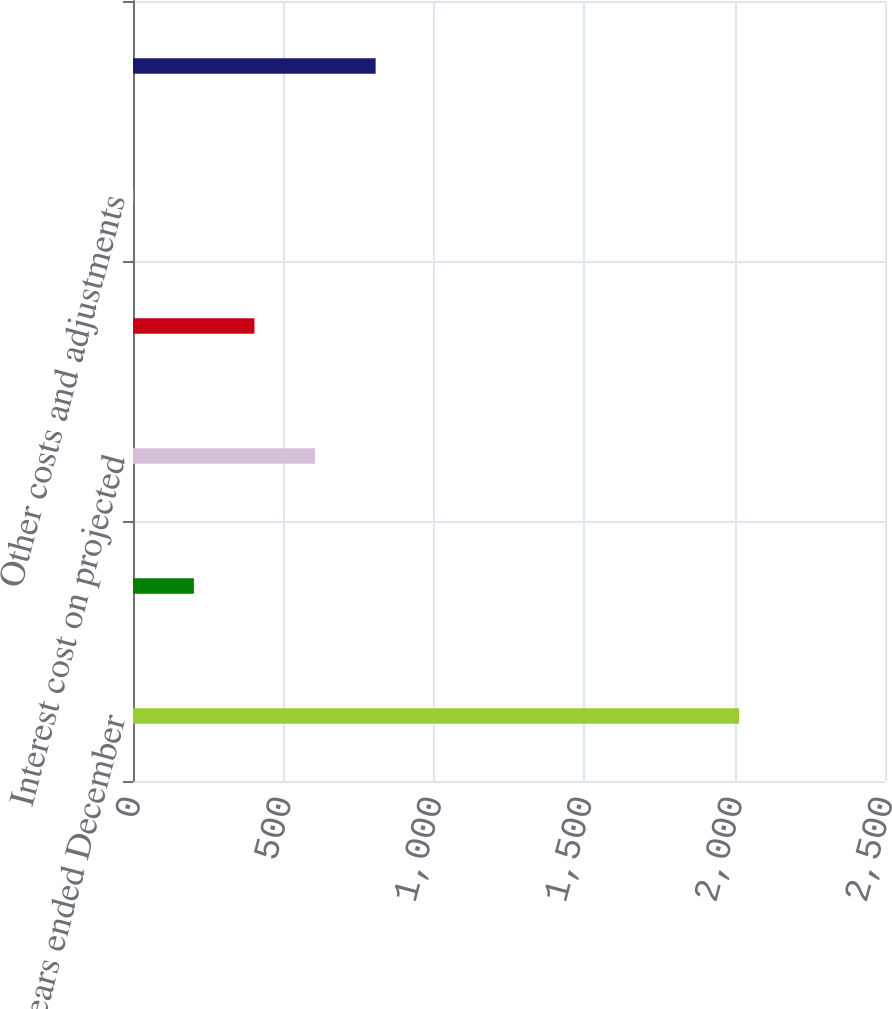Convert chart to OTSL. <chart><loc_0><loc_0><loc_500><loc_500><bar_chart><fcel>For the years ended December<fcel>Service cost - benefits earned<fcel>Interest cost on projected<fcel>Recognized actuarial loss<fcel>Other costs and adjustments<fcel>Net periodic benefit cost<nl><fcel>2015<fcel>202.4<fcel>605.2<fcel>403.8<fcel>1<fcel>806.6<nl></chart> 